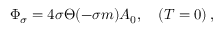Convert formula to latex. <formula><loc_0><loc_0><loc_500><loc_500>\Phi _ { \sigma } = 4 \sigma \Theta ( - \sigma m ) A _ { 0 } , \quad ( T = 0 ) \, ,</formula> 